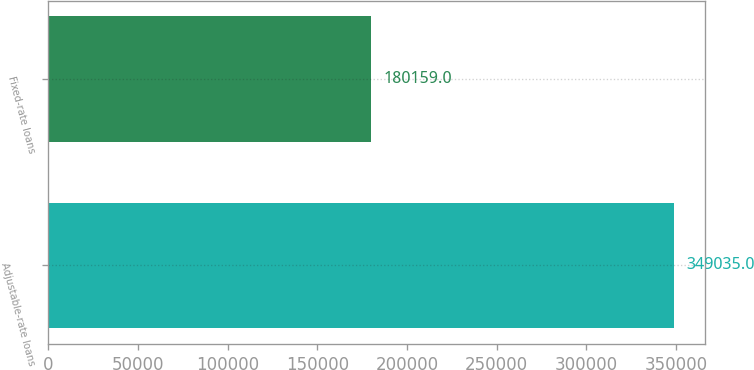<chart> <loc_0><loc_0><loc_500><loc_500><bar_chart><fcel>Adjustable-rate loans<fcel>Fixed-rate loans<nl><fcel>349035<fcel>180159<nl></chart> 